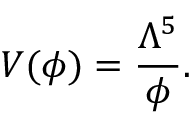Convert formula to latex. <formula><loc_0><loc_0><loc_500><loc_500>V ( \phi ) = \frac { \Lambda ^ { 5 } } { \phi } .</formula> 